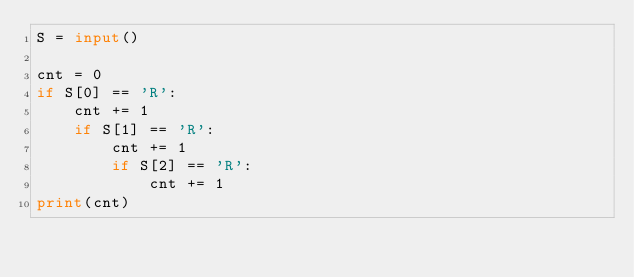<code> <loc_0><loc_0><loc_500><loc_500><_Python_>S = input()

cnt = 0
if S[0] == 'R':
    cnt += 1
    if S[1] == 'R':
        cnt += 1
        if S[2] == 'R':
            cnt += 1
print(cnt)</code> 